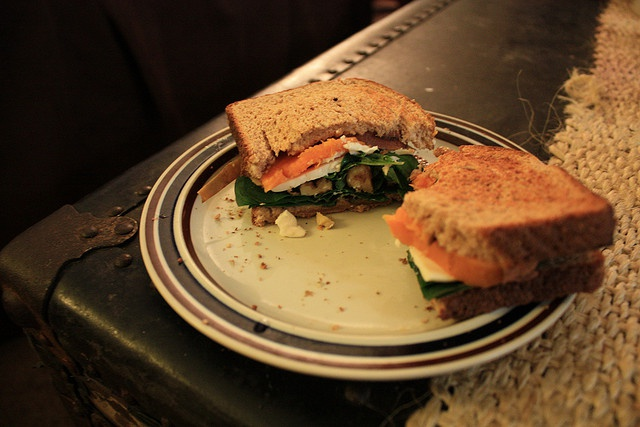Describe the objects in this image and their specific colors. I can see dining table in black, tan, and maroon tones, sandwich in black, red, maroon, and brown tones, and sandwich in black, orange, brown, and maroon tones in this image. 